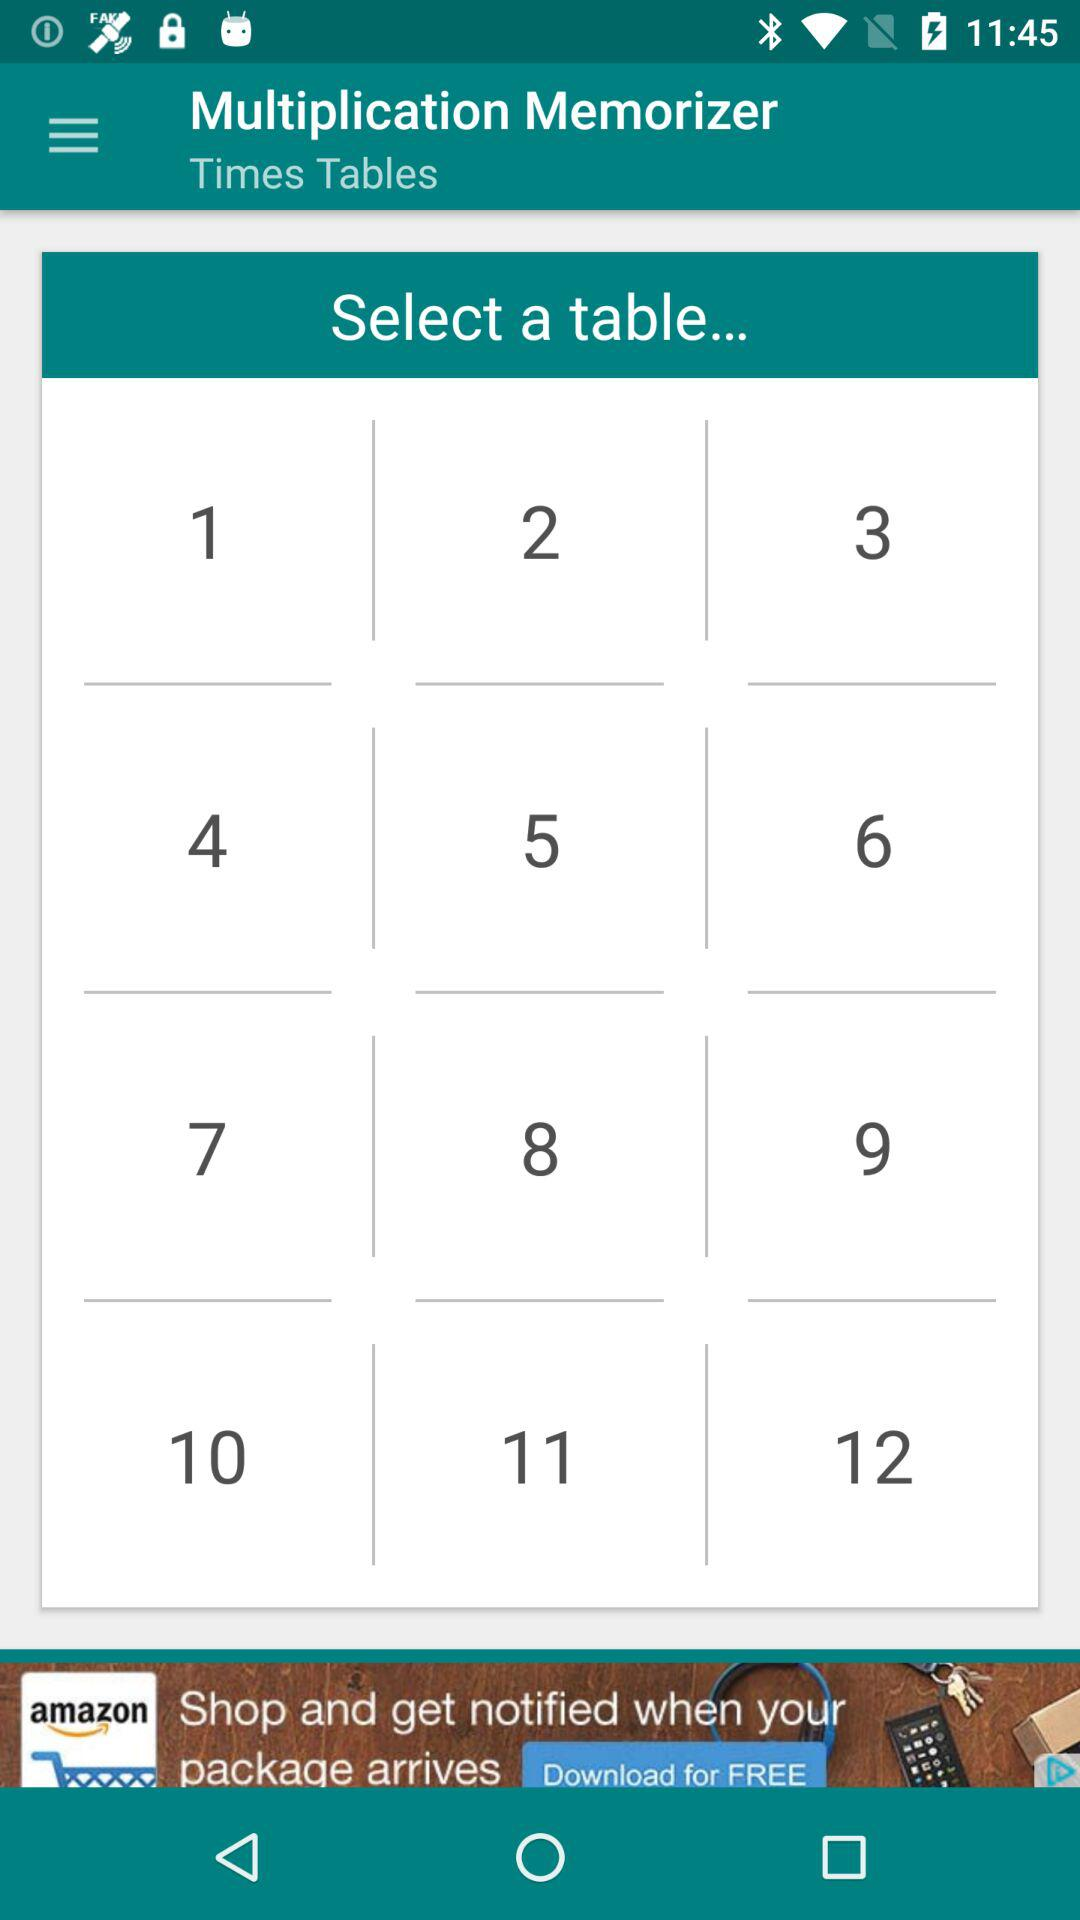What is the application name? The application name is "Multiplication Memorizer". 